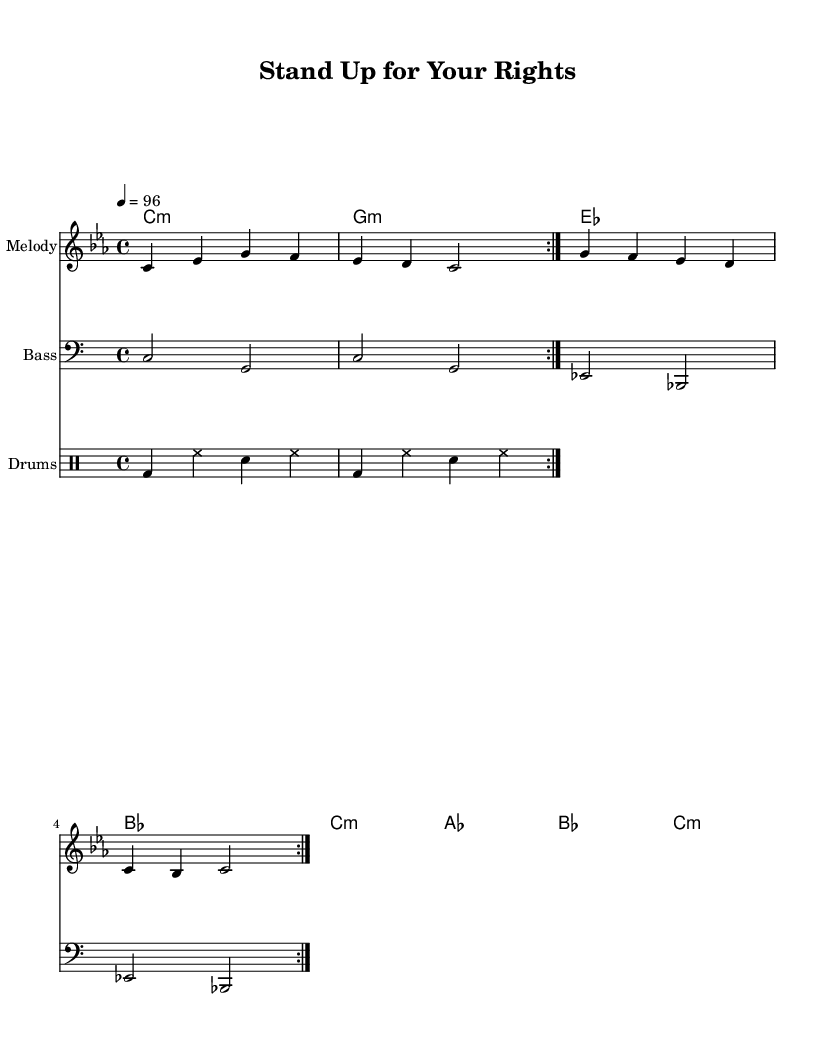What is the key signature of this music? The key signature indicated in the global section of the code is C minor, which has three flats: B flat, E flat, and A flat.
Answer: C minor What is the time signature of this music? The time signature specified in the global section is 4/4, indicating four beats per measure, with each beat being a quarter note.
Answer: 4/4 What is the tempo marking for this piece? The tempo marking given in the global section is "4 = 96", meaning that there are 96 quarter note beats per minute.
Answer: 96 How many measures are in the verse before the repeat? The verse consists of a total of four measures as described in the melody and verse chords section, which includes the specified sequence.
Answer: 4 What is the first line of lyrics in the verse? The verse lyrics are provided in the verseWords section. The first line starts with "In a world of greed and cor -- rup -- tion," which indicates the theme of the song.
Answer: In a world of greed and cor -- rup -- tion What chords are used in the chorus? The chorus chords are indicated in the chorusChords section, which are the following: C minor, A flat major, B flat major, and C minor, showing the harmonic structure.
Answer: C minor, A flat, B flat, C minor What is the main message reflected in the chorus lyrics? The chorus lyrics "Stand up, stand up for your rights, Don't let them keep us down," convey a message of empowerment and resistance against oppression, typical in reggae music.
Answer: Empowerment and resistance 